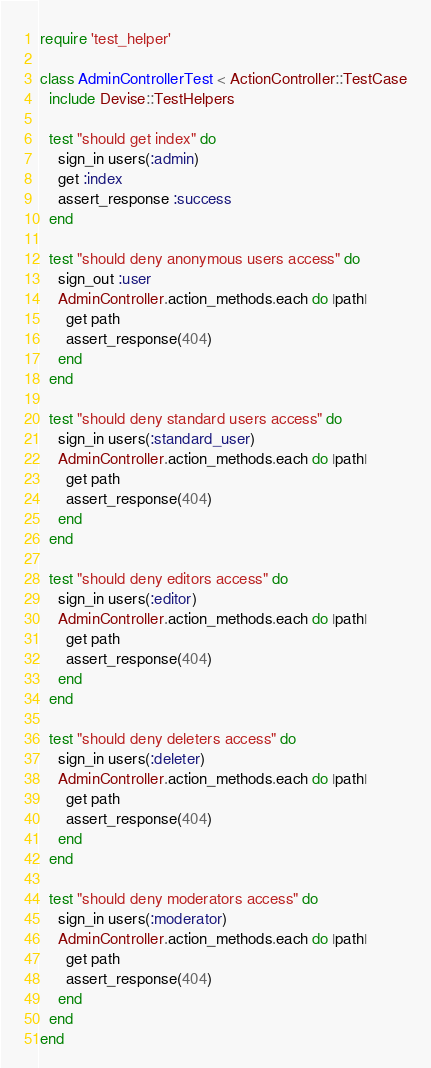Convert code to text. <code><loc_0><loc_0><loc_500><loc_500><_Ruby_>require 'test_helper'

class AdminControllerTest < ActionController::TestCase
  include Devise::TestHelpers

  test "should get index" do
    sign_in users(:admin)
    get :index
    assert_response :success
  end

  test "should deny anonymous users access" do
    sign_out :user
    AdminController.action_methods.each do |path|
      get path
      assert_response(404)
    end
  end

  test "should deny standard users access" do
    sign_in users(:standard_user)
    AdminController.action_methods.each do |path|
      get path
      assert_response(404)
    end
  end

  test "should deny editors access" do
    sign_in users(:editor)
    AdminController.action_methods.each do |path|
      get path
      assert_response(404)
    end
  end

  test "should deny deleters access" do
    sign_in users(:deleter)
    AdminController.action_methods.each do |path|
      get path
      assert_response(404)
    end
  end

  test "should deny moderators access" do
    sign_in users(:moderator)
    AdminController.action_methods.each do |path|
      get path
      assert_response(404)
    end
  end
end
</code> 